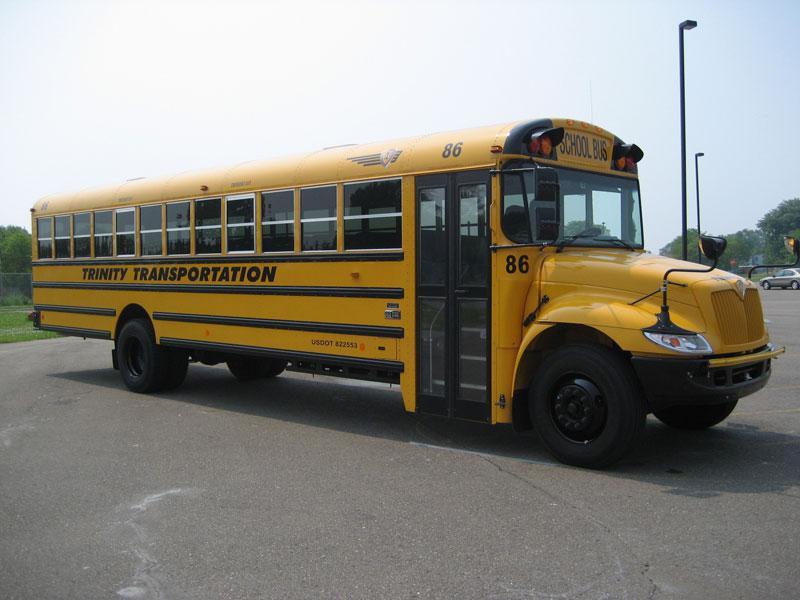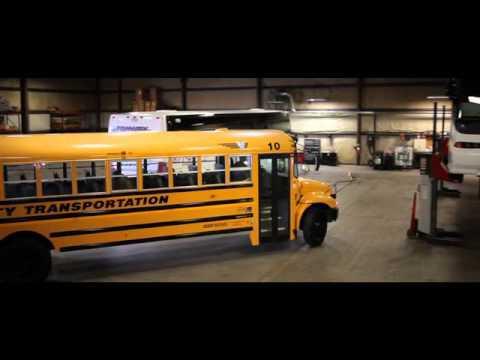The first image is the image on the left, the second image is the image on the right. Assess this claim about the two images: "The entry doors are visible on at least one of the buses.". Correct or not? Answer yes or no. Yes. 